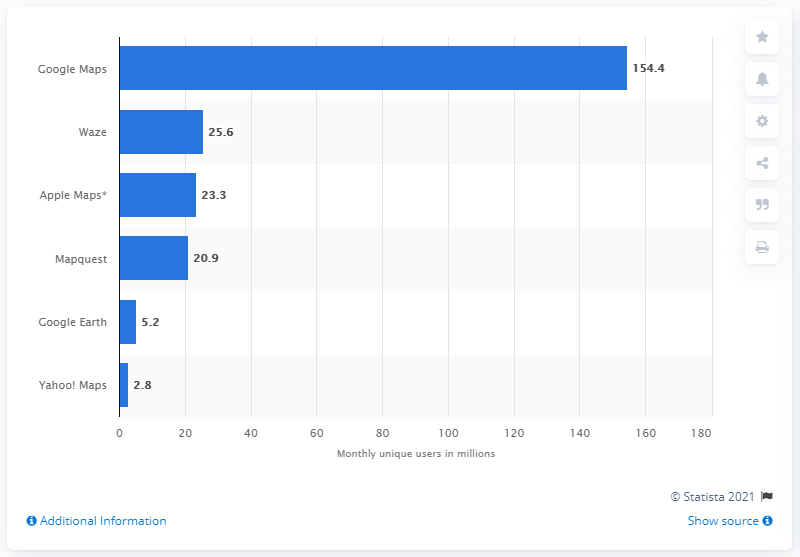Outline some significant characteristics in this image. In April 2018, a total of 154.4 users accessed the Google Maps app. 